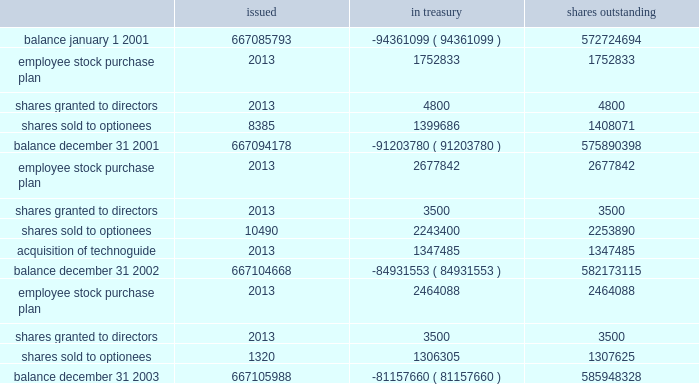Table of contents part ii , item 8 schlumberger limited ( schlumberger n.v. , incorporated in the netherlands antilles ) and subsidiary companies shares of common stock issued treasury shares outstanding .
See the notes to consolidated financial statements 39 / slb 2003 form 10-k .
The acquisition of technoguide accounted for what percentage of shares outstanding? 
Computations: (1347485 / 582173115)
Answer: 0.00231. 